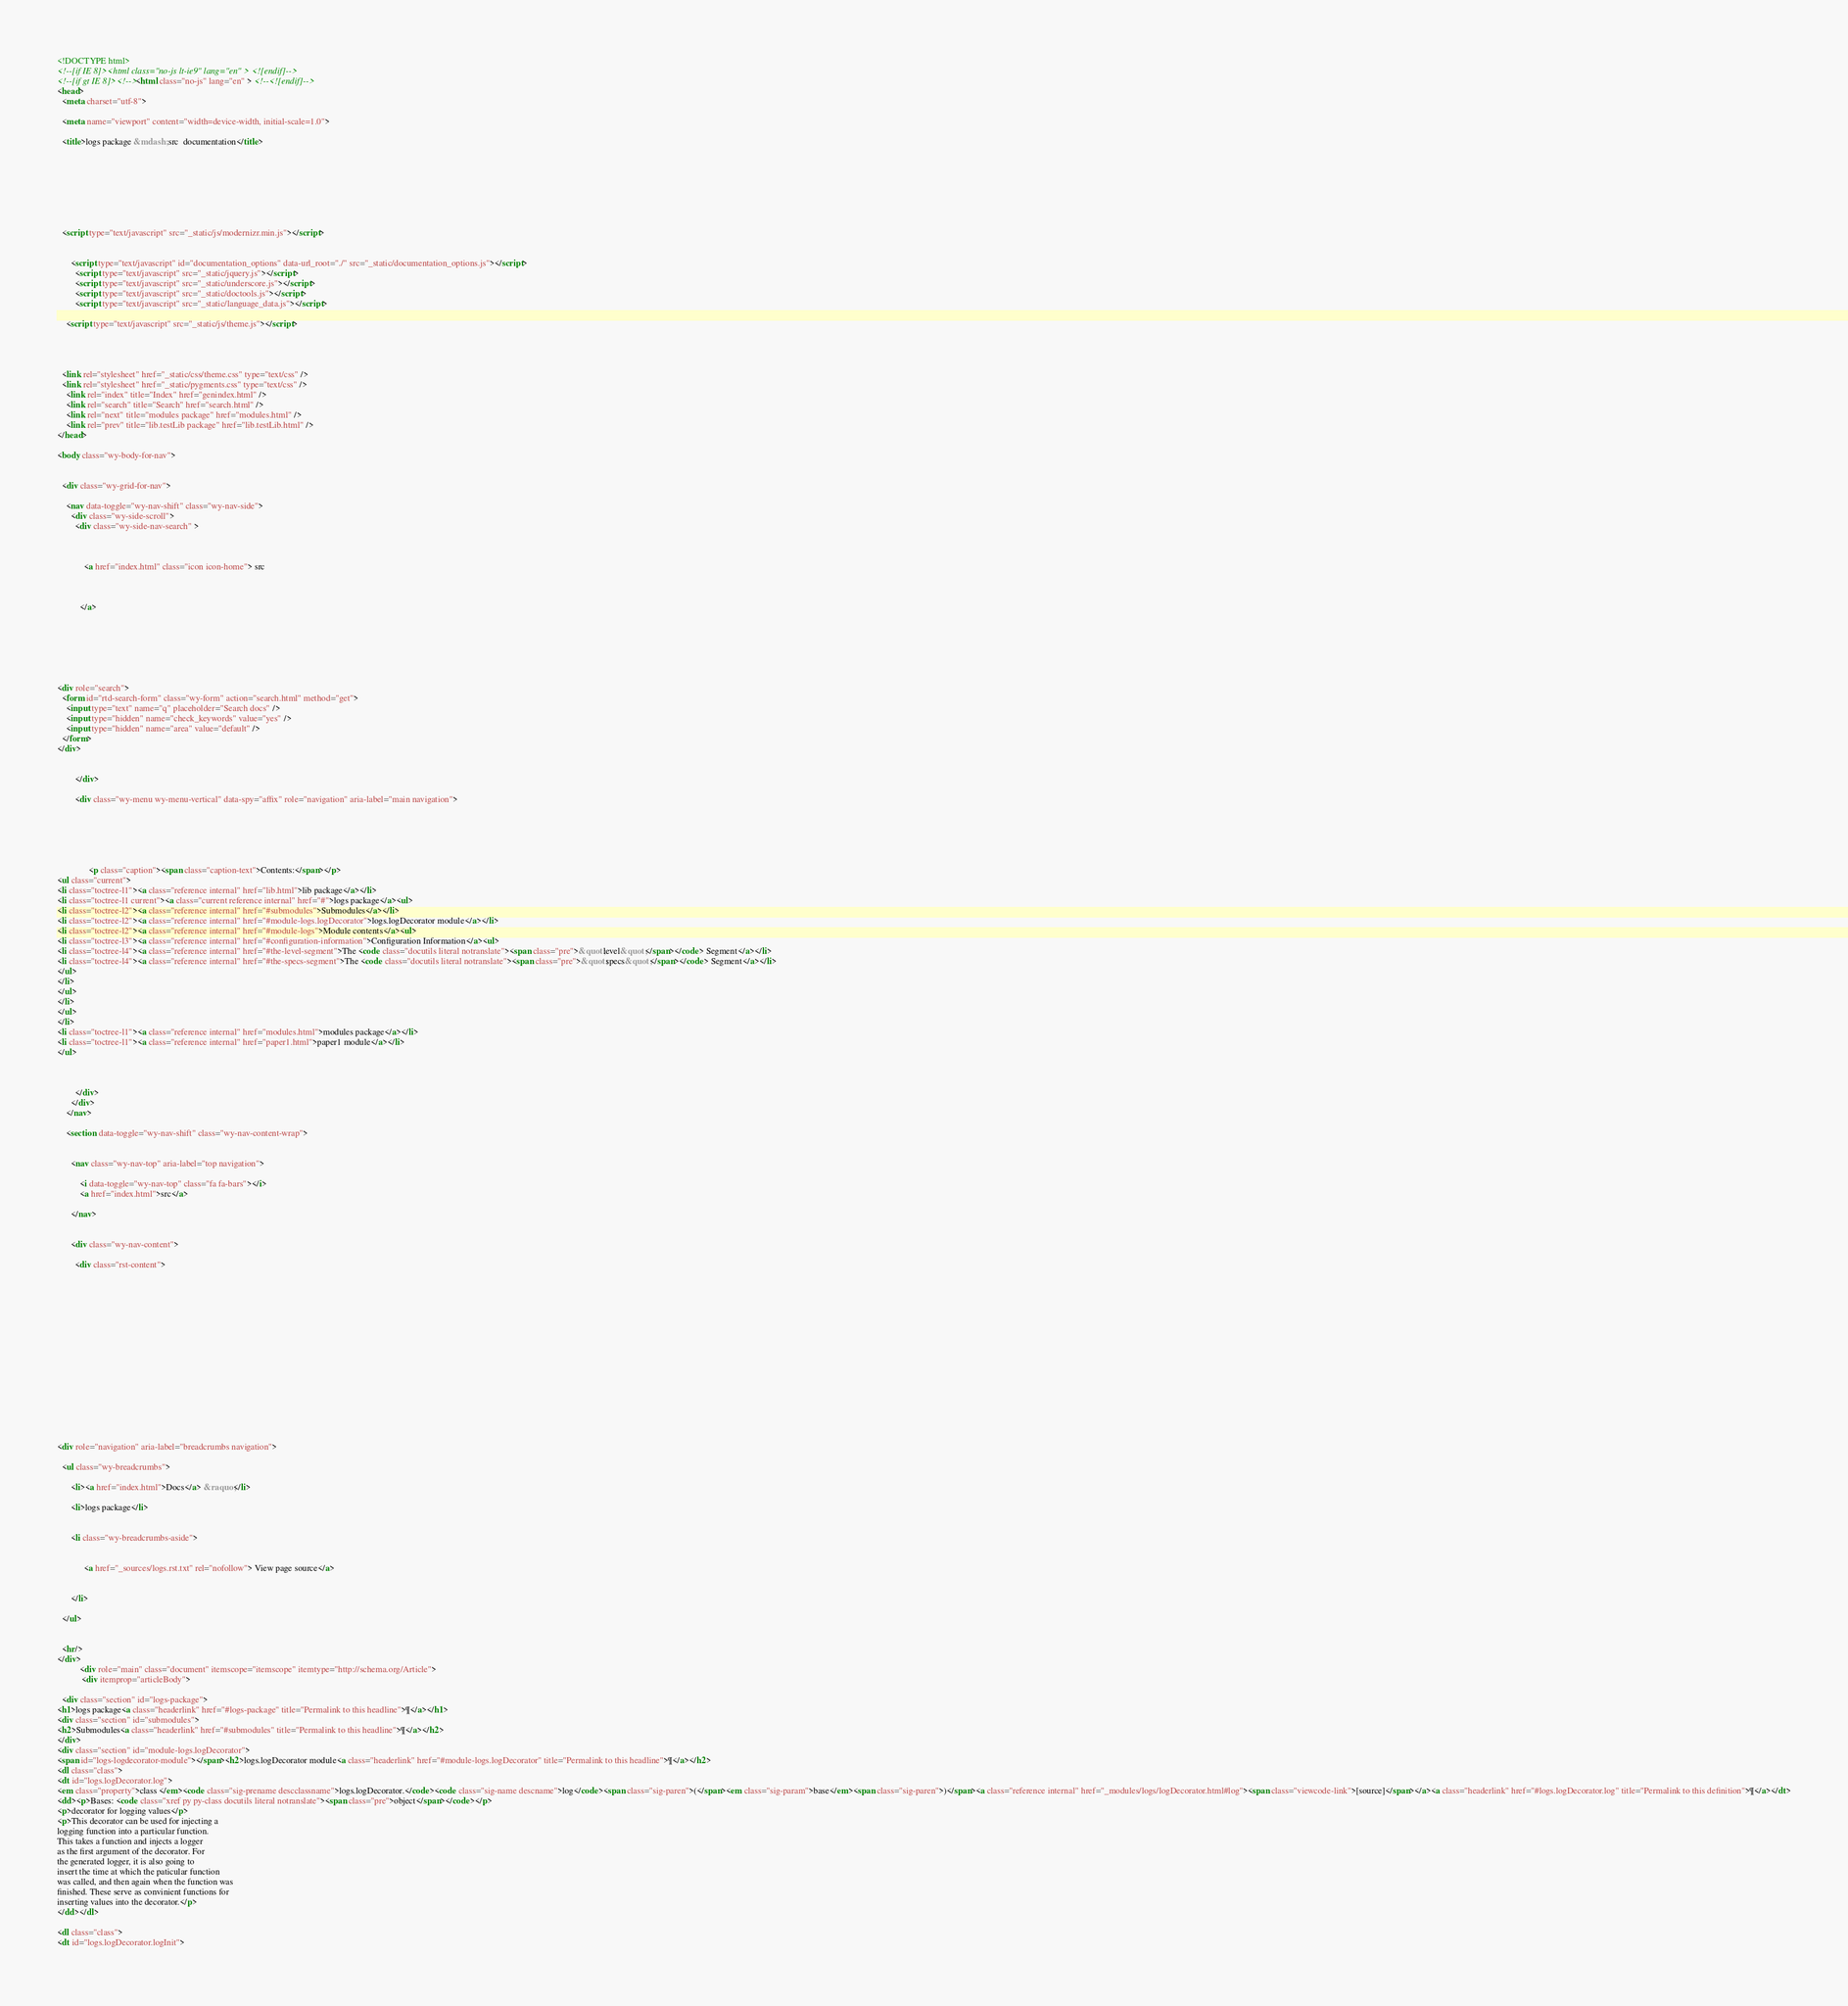<code> <loc_0><loc_0><loc_500><loc_500><_HTML_>

<!DOCTYPE html>
<!--[if IE 8]><html class="no-js lt-ie9" lang="en" > <![endif]-->
<!--[if gt IE 8]><!--> <html class="no-js" lang="en" > <!--<![endif]-->
<head>
  <meta charset="utf-8">
  
  <meta name="viewport" content="width=device-width, initial-scale=1.0">
  
  <title>logs package &mdash; src  documentation</title>
  

  
  
  
  

  
  <script type="text/javascript" src="_static/js/modernizr.min.js"></script>
  
    
      <script type="text/javascript" id="documentation_options" data-url_root="./" src="_static/documentation_options.js"></script>
        <script type="text/javascript" src="_static/jquery.js"></script>
        <script type="text/javascript" src="_static/underscore.js"></script>
        <script type="text/javascript" src="_static/doctools.js"></script>
        <script type="text/javascript" src="_static/language_data.js"></script>
    
    <script type="text/javascript" src="_static/js/theme.js"></script>

    

  
  <link rel="stylesheet" href="_static/css/theme.css" type="text/css" />
  <link rel="stylesheet" href="_static/pygments.css" type="text/css" />
    <link rel="index" title="Index" href="genindex.html" />
    <link rel="search" title="Search" href="search.html" />
    <link rel="next" title="modules package" href="modules.html" />
    <link rel="prev" title="lib.testLib package" href="lib.testLib.html" /> 
</head>

<body class="wy-body-for-nav">

   
  <div class="wy-grid-for-nav">
    
    <nav data-toggle="wy-nav-shift" class="wy-nav-side">
      <div class="wy-side-scroll">
        <div class="wy-side-nav-search" >
          

          
            <a href="index.html" class="icon icon-home"> src
          

          
          </a>

          
            
            
          

          
<div role="search">
  <form id="rtd-search-form" class="wy-form" action="search.html" method="get">
    <input type="text" name="q" placeholder="Search docs" />
    <input type="hidden" name="check_keywords" value="yes" />
    <input type="hidden" name="area" value="default" />
  </form>
</div>

          
        </div>

        <div class="wy-menu wy-menu-vertical" data-spy="affix" role="navigation" aria-label="main navigation">
          
            
            
              
            
            
              <p class="caption"><span class="caption-text">Contents:</span></p>
<ul class="current">
<li class="toctree-l1"><a class="reference internal" href="lib.html">lib package</a></li>
<li class="toctree-l1 current"><a class="current reference internal" href="#">logs package</a><ul>
<li class="toctree-l2"><a class="reference internal" href="#submodules">Submodules</a></li>
<li class="toctree-l2"><a class="reference internal" href="#module-logs.logDecorator">logs.logDecorator module</a></li>
<li class="toctree-l2"><a class="reference internal" href="#module-logs">Module contents</a><ul>
<li class="toctree-l3"><a class="reference internal" href="#configuration-information">Configuration Information</a><ul>
<li class="toctree-l4"><a class="reference internal" href="#the-level-segment">The <code class="docutils literal notranslate"><span class="pre">&quot;level&quot;</span></code> Segment</a></li>
<li class="toctree-l4"><a class="reference internal" href="#the-specs-segment">The <code class="docutils literal notranslate"><span class="pre">&quot;specs&quot;</span></code> Segment</a></li>
</ul>
</li>
</ul>
</li>
</ul>
</li>
<li class="toctree-l1"><a class="reference internal" href="modules.html">modules package</a></li>
<li class="toctree-l1"><a class="reference internal" href="paper1.html">paper1 module</a></li>
</ul>

            
          
        </div>
      </div>
    </nav>

    <section data-toggle="wy-nav-shift" class="wy-nav-content-wrap">

      
      <nav class="wy-nav-top" aria-label="top navigation">
        
          <i data-toggle="wy-nav-top" class="fa fa-bars"></i>
          <a href="index.html">src</a>
        
      </nav>


      <div class="wy-nav-content">
        
        <div class="rst-content">
        
          















<div role="navigation" aria-label="breadcrumbs navigation">

  <ul class="wy-breadcrumbs">
    
      <li><a href="index.html">Docs</a> &raquo;</li>
        
      <li>logs package</li>
    
    
      <li class="wy-breadcrumbs-aside">
        
            
            <a href="_sources/logs.rst.txt" rel="nofollow"> View page source</a>
          
        
      </li>
    
  </ul>

  
  <hr/>
</div>
          <div role="main" class="document" itemscope="itemscope" itemtype="http://schema.org/Article">
           <div itemprop="articleBody">
            
  <div class="section" id="logs-package">
<h1>logs package<a class="headerlink" href="#logs-package" title="Permalink to this headline">¶</a></h1>
<div class="section" id="submodules">
<h2>Submodules<a class="headerlink" href="#submodules" title="Permalink to this headline">¶</a></h2>
</div>
<div class="section" id="module-logs.logDecorator">
<span id="logs-logdecorator-module"></span><h2>logs.logDecorator module<a class="headerlink" href="#module-logs.logDecorator" title="Permalink to this headline">¶</a></h2>
<dl class="class">
<dt id="logs.logDecorator.log">
<em class="property">class </em><code class="sig-prename descclassname">logs.logDecorator.</code><code class="sig-name descname">log</code><span class="sig-paren">(</span><em class="sig-param">base</em><span class="sig-paren">)</span><a class="reference internal" href="_modules/logs/logDecorator.html#log"><span class="viewcode-link">[source]</span></a><a class="headerlink" href="#logs.logDecorator.log" title="Permalink to this definition">¶</a></dt>
<dd><p>Bases: <code class="xref py py-class docutils literal notranslate"><span class="pre">object</span></code></p>
<p>decorator for logging values</p>
<p>This decorator can be used for injecting a
logging function into a particular function.
This takes a function and injects a logger
as the first argument of the decorator. For
the generated logger, it is also going to
insert the time at which the paticular function
was called, and then again when the function was
finished. These serve as convinient functions for
inserting values into the decorator.</p>
</dd></dl>

<dl class="class">
<dt id="logs.logDecorator.logInit"></code> 